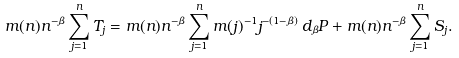Convert formula to latex. <formula><loc_0><loc_0><loc_500><loc_500>m ( n ) n ^ { - \beta } \sum _ { j = 1 } ^ { n } T _ { j } = m ( n ) n ^ { - \beta } \sum _ { j = 1 } ^ { n } m ( j ) ^ { - 1 } j ^ { - ( 1 - \beta ) } \, d _ { \beta } P + m ( n ) n ^ { - \beta } \sum _ { j = 1 } ^ { n } S _ { j } .</formula> 